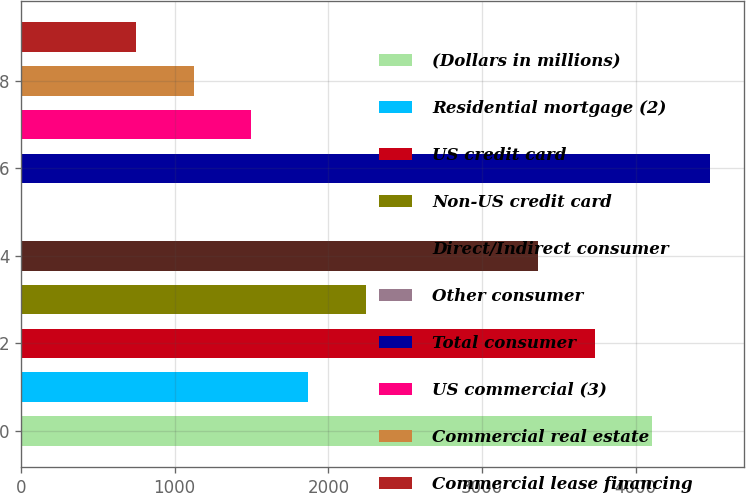Convert chart. <chart><loc_0><loc_0><loc_500><loc_500><bar_chart><fcel>(Dollars in millions)<fcel>Residential mortgage (2)<fcel>US credit card<fcel>Non-US credit card<fcel>Direct/Indirect consumer<fcel>Other consumer<fcel>Total consumer<fcel>US commercial (3)<fcel>Commercial real estate<fcel>Commercial lease financing<nl><fcel>4109.2<fcel>1870<fcel>3736<fcel>2243.2<fcel>3362.8<fcel>4<fcel>4482.4<fcel>1496.8<fcel>1123.6<fcel>750.4<nl></chart> 